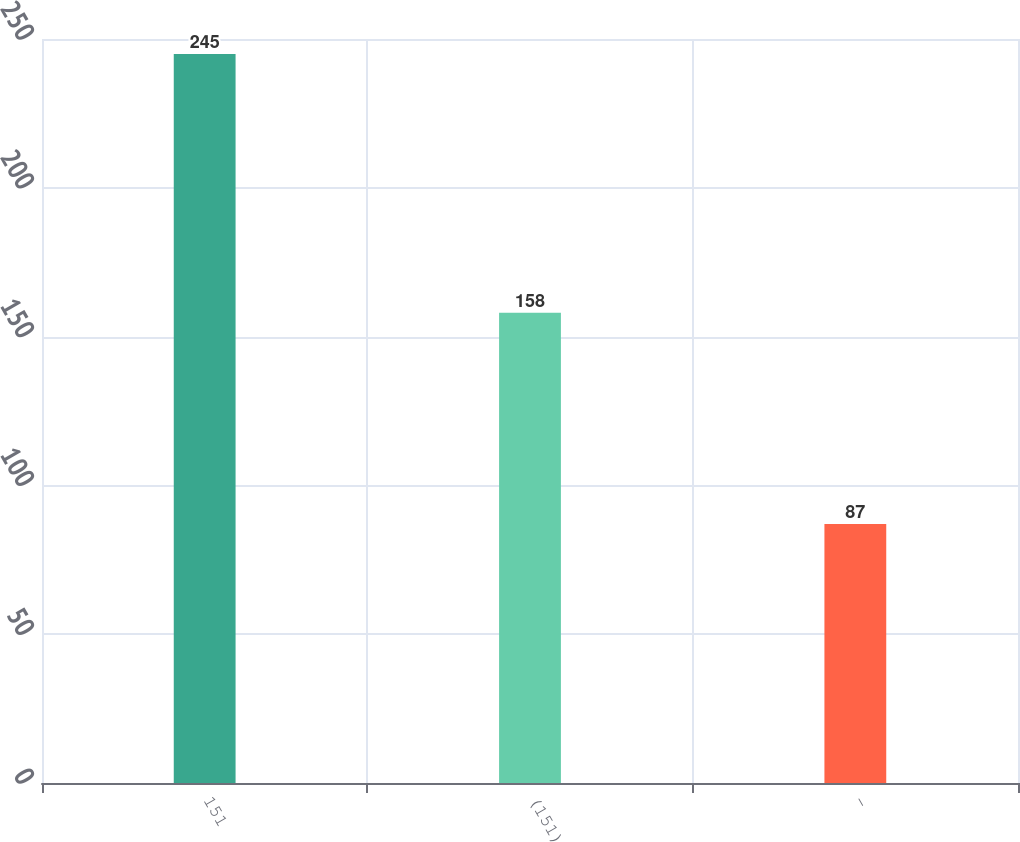Convert chart. <chart><loc_0><loc_0><loc_500><loc_500><bar_chart><fcel>151<fcel>(151)<fcel>-<nl><fcel>245<fcel>158<fcel>87<nl></chart> 